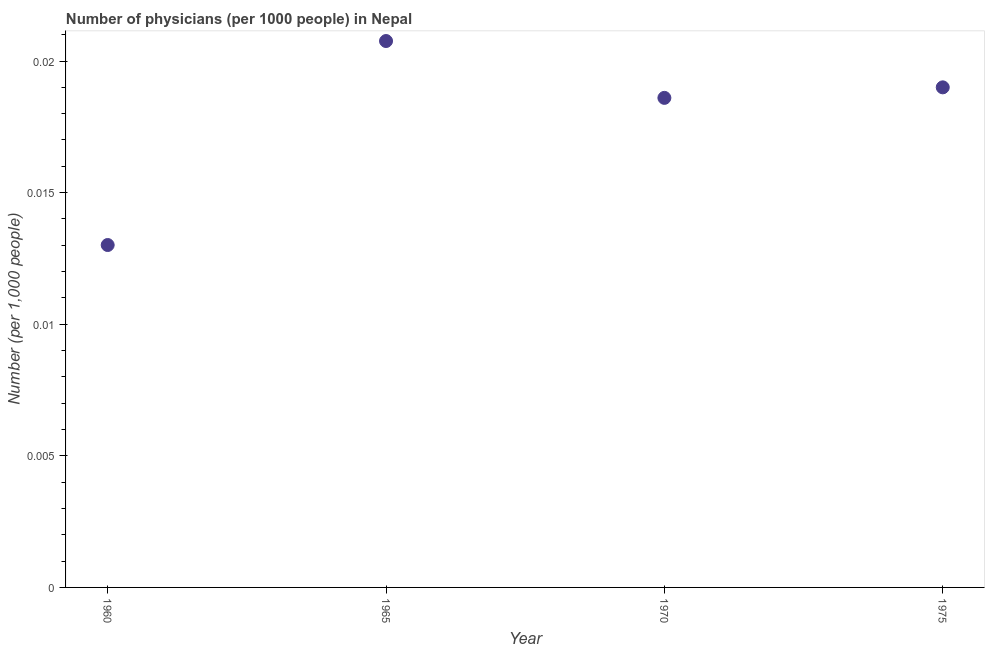What is the number of physicians in 1970?
Offer a terse response. 0.02. Across all years, what is the maximum number of physicians?
Ensure brevity in your answer.  0.02. Across all years, what is the minimum number of physicians?
Offer a terse response. 0.01. In which year was the number of physicians maximum?
Your answer should be compact. 1965. What is the sum of the number of physicians?
Offer a terse response. 0.07. What is the difference between the number of physicians in 1965 and 1970?
Keep it short and to the point. 0. What is the average number of physicians per year?
Make the answer very short. 0.02. What is the median number of physicians?
Make the answer very short. 0.02. Do a majority of the years between 1975 and 1965 (inclusive) have number of physicians greater than 0.012 ?
Keep it short and to the point. No. What is the ratio of the number of physicians in 1965 to that in 1970?
Offer a very short reply. 1.12. Is the number of physicians in 1965 less than that in 1975?
Ensure brevity in your answer.  No. What is the difference between the highest and the second highest number of physicians?
Your response must be concise. 0. What is the difference between the highest and the lowest number of physicians?
Your answer should be compact. 0.01. Does the number of physicians monotonically increase over the years?
Your answer should be compact. No. What is the difference between two consecutive major ticks on the Y-axis?
Your answer should be compact. 0.01. Are the values on the major ticks of Y-axis written in scientific E-notation?
Make the answer very short. No. What is the title of the graph?
Provide a short and direct response. Number of physicians (per 1000 people) in Nepal. What is the label or title of the X-axis?
Keep it short and to the point. Year. What is the label or title of the Y-axis?
Provide a succinct answer. Number (per 1,0 people). What is the Number (per 1,000 people) in 1960?
Provide a short and direct response. 0.01. What is the Number (per 1,000 people) in 1965?
Make the answer very short. 0.02. What is the Number (per 1,000 people) in 1970?
Make the answer very short. 0.02. What is the Number (per 1,000 people) in 1975?
Offer a terse response. 0.02. What is the difference between the Number (per 1,000 people) in 1960 and 1965?
Ensure brevity in your answer.  -0.01. What is the difference between the Number (per 1,000 people) in 1960 and 1970?
Offer a very short reply. -0.01. What is the difference between the Number (per 1,000 people) in 1960 and 1975?
Offer a terse response. -0.01. What is the difference between the Number (per 1,000 people) in 1965 and 1970?
Your answer should be very brief. 0. What is the difference between the Number (per 1,000 people) in 1965 and 1975?
Offer a terse response. 0. What is the difference between the Number (per 1,000 people) in 1970 and 1975?
Provide a short and direct response. -0. What is the ratio of the Number (per 1,000 people) in 1960 to that in 1965?
Your answer should be compact. 0.63. What is the ratio of the Number (per 1,000 people) in 1960 to that in 1970?
Offer a terse response. 0.7. What is the ratio of the Number (per 1,000 people) in 1960 to that in 1975?
Provide a succinct answer. 0.69. What is the ratio of the Number (per 1,000 people) in 1965 to that in 1970?
Give a very brief answer. 1.12. What is the ratio of the Number (per 1,000 people) in 1965 to that in 1975?
Make the answer very short. 1.09. 